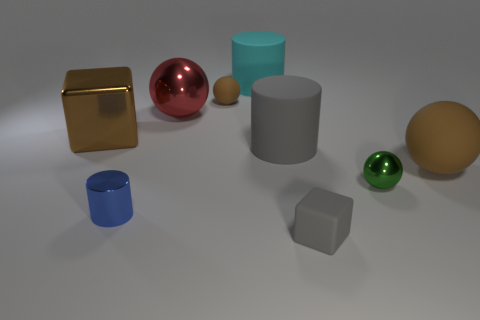Subtract 1 spheres. How many spheres are left? 3 Add 1 red balls. How many objects exist? 10 Subtract all cubes. How many objects are left? 7 Add 9 cyan objects. How many cyan objects exist? 10 Subtract 0 yellow spheres. How many objects are left? 9 Subtract all shiny objects. Subtract all big gray cylinders. How many objects are left? 4 Add 3 cyan things. How many cyan things are left? 4 